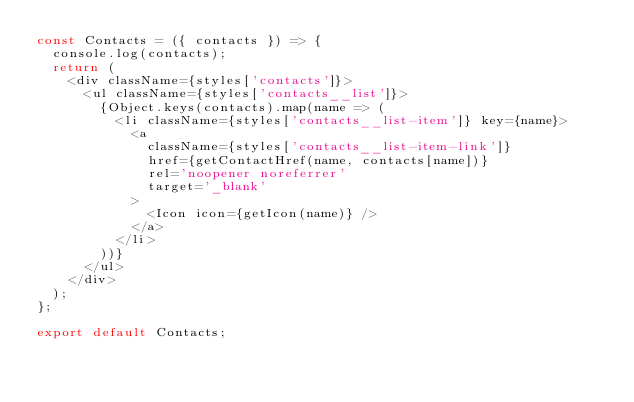<code> <loc_0><loc_0><loc_500><loc_500><_JavaScript_>const Contacts = ({ contacts }) => {
	console.log(contacts);
	return (
		<div className={styles['contacts']}>
			<ul className={styles['contacts__list']}>
				{Object.keys(contacts).map(name => (
					<li className={styles['contacts__list-item']} key={name}>
						<a
							className={styles['contacts__list-item-link']}
							href={getContactHref(name, contacts[name])}
							rel='noopener noreferrer'
							target='_blank'
						>
							<Icon icon={getIcon(name)} />
						</a>
					</li>
				))}
			</ul>
		</div>
	);
};

export default Contacts;
</code> 